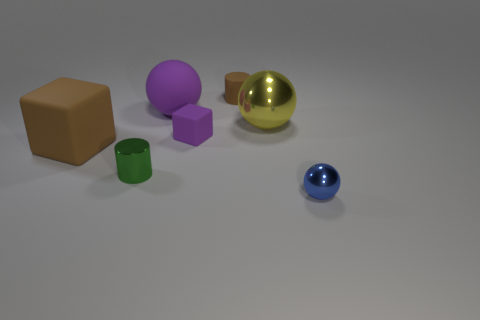Add 2 brown rubber things. How many objects exist? 9 Subtract 0 green cubes. How many objects are left? 7 Subtract all balls. How many objects are left? 4 Subtract all cyan rubber balls. Subtract all purple matte things. How many objects are left? 5 Add 4 tiny cylinders. How many tiny cylinders are left? 6 Add 5 rubber balls. How many rubber balls exist? 6 